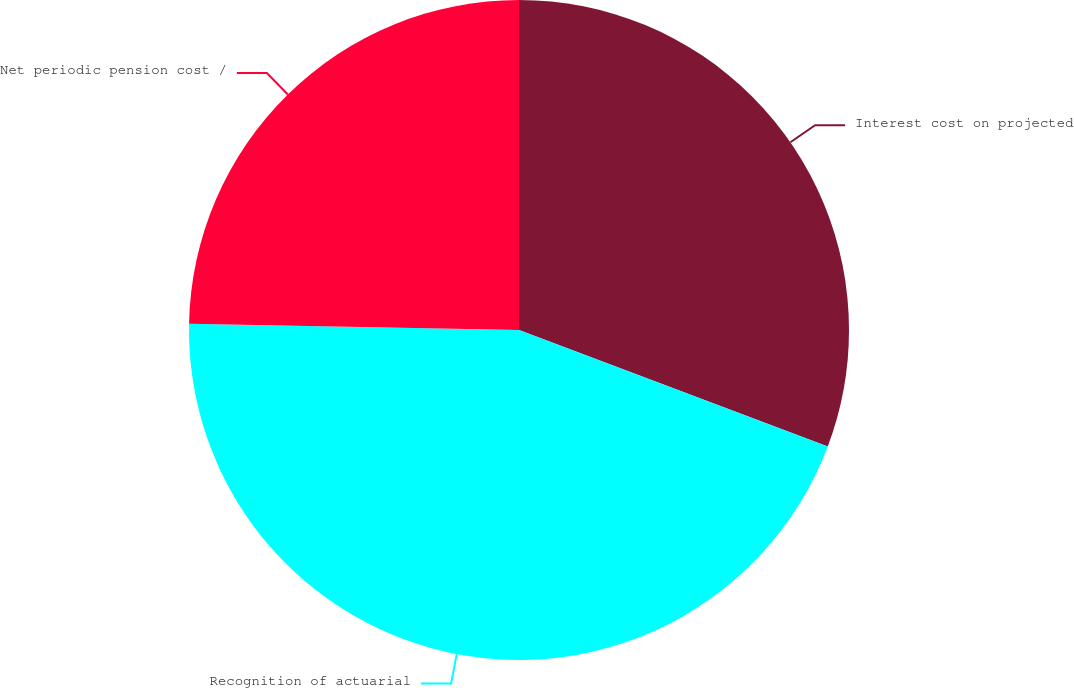<chart> <loc_0><loc_0><loc_500><loc_500><pie_chart><fcel>Interest cost on projected<fcel>Recognition of actuarial<fcel>Net periodic pension cost /<nl><fcel>30.74%<fcel>44.56%<fcel>24.7%<nl></chart> 